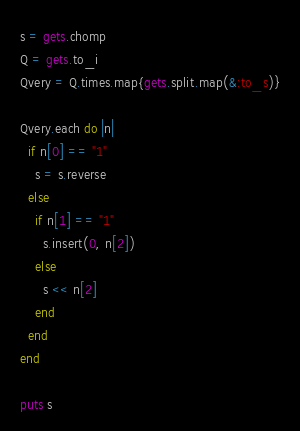<code> <loc_0><loc_0><loc_500><loc_500><_Ruby_>s = gets.chomp
Q = gets.to_i
Qvery = Q.times.map{gets.split.map(&:to_s)}

Qvery.each do |n|
  if n[0] == "1"
    s = s.reverse
  else
    if n[1] == "1"
      s.insert(0, n[2])
    else
      s << n[2]
    end
  end
end

puts s</code> 